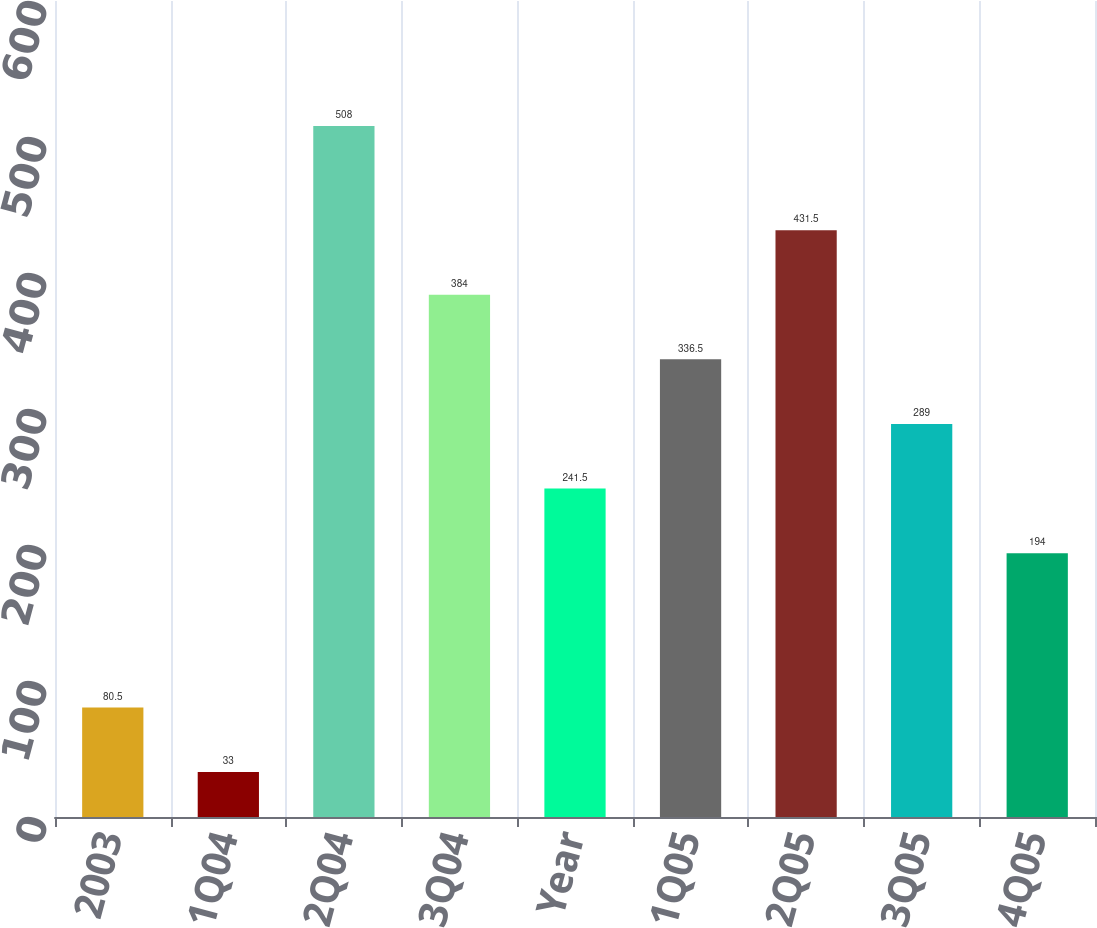Convert chart. <chart><loc_0><loc_0><loc_500><loc_500><bar_chart><fcel>2003<fcel>1Q04<fcel>2Q04<fcel>3Q04<fcel>Year<fcel>1Q05<fcel>2Q05<fcel>3Q05<fcel>4Q05<nl><fcel>80.5<fcel>33<fcel>508<fcel>384<fcel>241.5<fcel>336.5<fcel>431.5<fcel>289<fcel>194<nl></chart> 